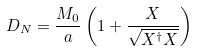<formula> <loc_0><loc_0><loc_500><loc_500>D _ { N } = \frac { M _ { 0 } } { a } \left ( 1 + \frac { X } { \sqrt { X ^ { \dagger } X } } \right )</formula> 